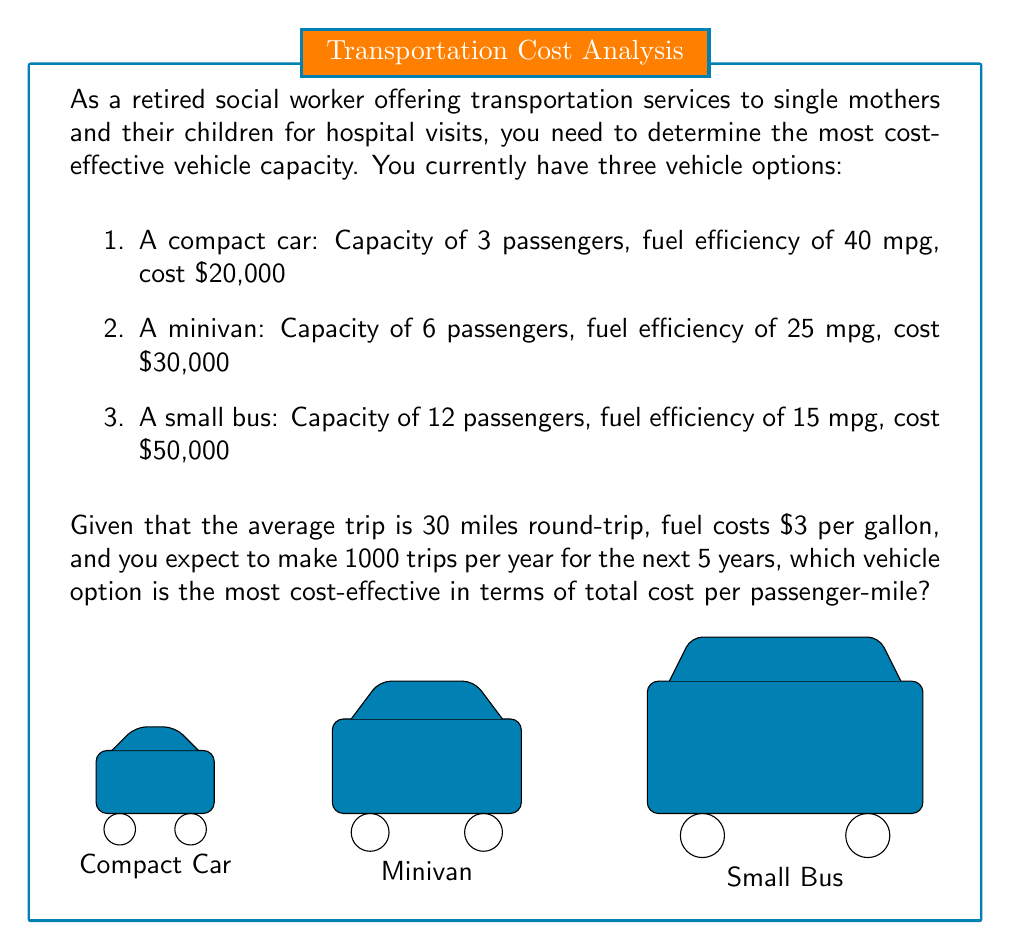Provide a solution to this math problem. To determine the most cost-effective vehicle option, we need to calculate the total cost per passenger-mile for each vehicle over the 5-year period. Let's break it down step-by-step:

1. Calculate total miles driven:
   $1000 \text{ trips/year} \times 30 \text{ miles/trip} \times 5 \text{ years} = 150,000 \text{ miles}$

2. Calculate fuel consumption for each vehicle:
   - Compact car: $150,000 \text{ miles} \div 40 \text{ mpg} = 3,750 \text{ gallons}$
   - Minivan: $150,000 \text{ miles} \div 25 \text{ mpg} = 6,000 \text{ gallons}$
   - Small bus: $150,000 \text{ miles} \div 15 \text{ mpg} = 10,000 \text{ gallons}$

3. Calculate fuel cost for each vehicle:
   - Compact car: $3,750 \text{ gallons} \times \$3/\text{gallon} = \$11,250$
   - Minivan: $6,000 \text{ gallons} \times \$3/\text{gallon} = \$18,000$
   - Small bus: $10,000 \text{ gallons} \times \$3/\text{gallon} = \$30,000$

4. Calculate total cost (vehicle + fuel) for each option:
   - Compact car: $\$20,000 + \$11,250 = \$31,250$
   - Minivan: $\$30,000 + \$18,000 = \$48,000$
   - Small bus: $\$50,000 + \$30,000 = \$80,000$

5. Calculate total passenger-miles for each vehicle:
   - Compact car: $150,000 \text{ miles} \times 3 \text{ passengers} = 450,000 \text{ passenger-miles}$
   - Minivan: $150,000 \text{ miles} \times 6 \text{ passengers} = 900,000 \text{ passenger-miles}$
   - Small bus: $150,000 \text{ miles} \times 12 \text{ passengers} = 1,800,000 \text{ passenger-miles}$

6. Calculate cost per passenger-mile for each vehicle:
   - Compact car: $\frac{\$31,250}{450,000 \text{ passenger-miles}} = \$0.0694 \text{ per passenger-mile}$
   - Minivan: $\frac{\$48,000}{900,000 \text{ passenger-miles}} = \$0.0533 \text{ per passenger-mile}$
   - Small bus: $\frac{\$80,000}{1,800,000 \text{ passenger-miles}} = \$0.0444 \text{ per passenger-mile}$

The small bus has the lowest cost per passenger-mile, making it the most cost-effective option for the given scenario.
Answer: Small bus at $0.0444 per passenger-mile 